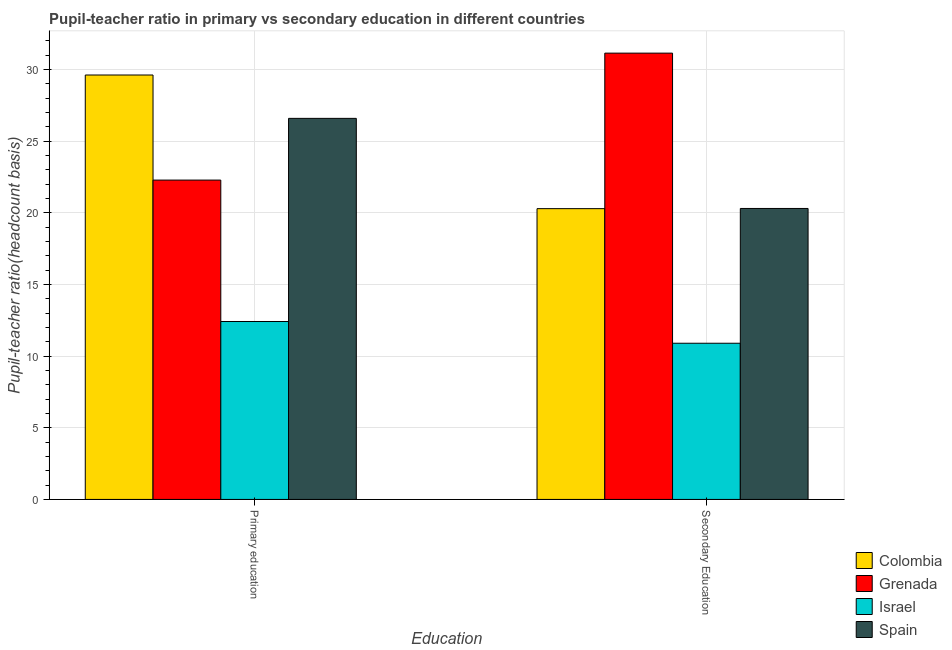How many groups of bars are there?
Your response must be concise. 2. Are the number of bars on each tick of the X-axis equal?
Ensure brevity in your answer.  Yes. What is the label of the 2nd group of bars from the left?
Ensure brevity in your answer.  Secondary Education. What is the pupil teacher ratio on secondary education in Israel?
Ensure brevity in your answer.  10.9. Across all countries, what is the maximum pupil teacher ratio on secondary education?
Give a very brief answer. 31.13. Across all countries, what is the minimum pupil-teacher ratio in primary education?
Give a very brief answer. 12.41. In which country was the pupil teacher ratio on secondary education maximum?
Your answer should be very brief. Grenada. In which country was the pupil teacher ratio on secondary education minimum?
Give a very brief answer. Israel. What is the total pupil teacher ratio on secondary education in the graph?
Offer a very short reply. 82.61. What is the difference between the pupil teacher ratio on secondary education in Spain and that in Grenada?
Keep it short and to the point. -10.84. What is the difference between the pupil teacher ratio on secondary education in Colombia and the pupil-teacher ratio in primary education in Israel?
Keep it short and to the point. 7.87. What is the average pupil teacher ratio on secondary education per country?
Ensure brevity in your answer.  20.65. What is the difference between the pupil teacher ratio on secondary education and pupil-teacher ratio in primary education in Israel?
Your response must be concise. -1.52. In how many countries, is the pupil teacher ratio on secondary education greater than 24 ?
Provide a succinct answer. 1. What is the ratio of the pupil-teacher ratio in primary education in Grenada to that in Spain?
Provide a succinct answer. 0.84. What does the 2nd bar from the left in Secondary Education represents?
Ensure brevity in your answer.  Grenada. What does the 3rd bar from the right in Secondary Education represents?
Offer a terse response. Grenada. Are all the bars in the graph horizontal?
Your answer should be compact. No. Does the graph contain any zero values?
Provide a short and direct response. No. Does the graph contain grids?
Provide a short and direct response. Yes. Where does the legend appear in the graph?
Offer a terse response. Bottom right. What is the title of the graph?
Offer a very short reply. Pupil-teacher ratio in primary vs secondary education in different countries. Does "Burundi" appear as one of the legend labels in the graph?
Provide a succinct answer. No. What is the label or title of the X-axis?
Keep it short and to the point. Education. What is the label or title of the Y-axis?
Offer a terse response. Pupil-teacher ratio(headcount basis). What is the Pupil-teacher ratio(headcount basis) of Colombia in Primary education?
Provide a succinct answer. 29.61. What is the Pupil-teacher ratio(headcount basis) in Grenada in Primary education?
Ensure brevity in your answer.  22.28. What is the Pupil-teacher ratio(headcount basis) in Israel in Primary education?
Ensure brevity in your answer.  12.41. What is the Pupil-teacher ratio(headcount basis) in Spain in Primary education?
Offer a terse response. 26.58. What is the Pupil-teacher ratio(headcount basis) of Colombia in Secondary Education?
Give a very brief answer. 20.29. What is the Pupil-teacher ratio(headcount basis) of Grenada in Secondary Education?
Your answer should be very brief. 31.13. What is the Pupil-teacher ratio(headcount basis) of Israel in Secondary Education?
Your response must be concise. 10.9. What is the Pupil-teacher ratio(headcount basis) in Spain in Secondary Education?
Offer a terse response. 20.3. Across all Education, what is the maximum Pupil-teacher ratio(headcount basis) of Colombia?
Your answer should be compact. 29.61. Across all Education, what is the maximum Pupil-teacher ratio(headcount basis) in Grenada?
Provide a short and direct response. 31.13. Across all Education, what is the maximum Pupil-teacher ratio(headcount basis) of Israel?
Your answer should be very brief. 12.41. Across all Education, what is the maximum Pupil-teacher ratio(headcount basis) of Spain?
Your answer should be very brief. 26.58. Across all Education, what is the minimum Pupil-teacher ratio(headcount basis) of Colombia?
Your response must be concise. 20.29. Across all Education, what is the minimum Pupil-teacher ratio(headcount basis) of Grenada?
Your answer should be very brief. 22.28. Across all Education, what is the minimum Pupil-teacher ratio(headcount basis) of Israel?
Your response must be concise. 10.9. Across all Education, what is the minimum Pupil-teacher ratio(headcount basis) of Spain?
Provide a succinct answer. 20.3. What is the total Pupil-teacher ratio(headcount basis) of Colombia in the graph?
Your answer should be very brief. 49.89. What is the total Pupil-teacher ratio(headcount basis) of Grenada in the graph?
Offer a very short reply. 53.41. What is the total Pupil-teacher ratio(headcount basis) of Israel in the graph?
Your response must be concise. 23.31. What is the total Pupil-teacher ratio(headcount basis) in Spain in the graph?
Give a very brief answer. 46.88. What is the difference between the Pupil-teacher ratio(headcount basis) in Colombia in Primary education and that in Secondary Education?
Offer a terse response. 9.32. What is the difference between the Pupil-teacher ratio(headcount basis) of Grenada in Primary education and that in Secondary Education?
Your response must be concise. -8.86. What is the difference between the Pupil-teacher ratio(headcount basis) of Israel in Primary education and that in Secondary Education?
Offer a very short reply. 1.52. What is the difference between the Pupil-teacher ratio(headcount basis) of Spain in Primary education and that in Secondary Education?
Make the answer very short. 6.28. What is the difference between the Pupil-teacher ratio(headcount basis) in Colombia in Primary education and the Pupil-teacher ratio(headcount basis) in Grenada in Secondary Education?
Ensure brevity in your answer.  -1.53. What is the difference between the Pupil-teacher ratio(headcount basis) in Colombia in Primary education and the Pupil-teacher ratio(headcount basis) in Israel in Secondary Education?
Offer a terse response. 18.71. What is the difference between the Pupil-teacher ratio(headcount basis) in Colombia in Primary education and the Pupil-teacher ratio(headcount basis) in Spain in Secondary Education?
Offer a very short reply. 9.31. What is the difference between the Pupil-teacher ratio(headcount basis) of Grenada in Primary education and the Pupil-teacher ratio(headcount basis) of Israel in Secondary Education?
Your response must be concise. 11.38. What is the difference between the Pupil-teacher ratio(headcount basis) of Grenada in Primary education and the Pupil-teacher ratio(headcount basis) of Spain in Secondary Education?
Your response must be concise. 1.98. What is the difference between the Pupil-teacher ratio(headcount basis) in Israel in Primary education and the Pupil-teacher ratio(headcount basis) in Spain in Secondary Education?
Provide a succinct answer. -7.89. What is the average Pupil-teacher ratio(headcount basis) of Colombia per Education?
Provide a short and direct response. 24.95. What is the average Pupil-teacher ratio(headcount basis) in Grenada per Education?
Give a very brief answer. 26.71. What is the average Pupil-teacher ratio(headcount basis) in Israel per Education?
Offer a very short reply. 11.65. What is the average Pupil-teacher ratio(headcount basis) in Spain per Education?
Give a very brief answer. 23.44. What is the difference between the Pupil-teacher ratio(headcount basis) of Colombia and Pupil-teacher ratio(headcount basis) of Grenada in Primary education?
Keep it short and to the point. 7.33. What is the difference between the Pupil-teacher ratio(headcount basis) of Colombia and Pupil-teacher ratio(headcount basis) of Israel in Primary education?
Offer a terse response. 17.2. What is the difference between the Pupil-teacher ratio(headcount basis) in Colombia and Pupil-teacher ratio(headcount basis) in Spain in Primary education?
Your response must be concise. 3.02. What is the difference between the Pupil-teacher ratio(headcount basis) in Grenada and Pupil-teacher ratio(headcount basis) in Israel in Primary education?
Your answer should be compact. 9.87. What is the difference between the Pupil-teacher ratio(headcount basis) of Grenada and Pupil-teacher ratio(headcount basis) of Spain in Primary education?
Your response must be concise. -4.31. What is the difference between the Pupil-teacher ratio(headcount basis) of Israel and Pupil-teacher ratio(headcount basis) of Spain in Primary education?
Your answer should be compact. -14.17. What is the difference between the Pupil-teacher ratio(headcount basis) in Colombia and Pupil-teacher ratio(headcount basis) in Grenada in Secondary Education?
Offer a terse response. -10.85. What is the difference between the Pupil-teacher ratio(headcount basis) of Colombia and Pupil-teacher ratio(headcount basis) of Israel in Secondary Education?
Keep it short and to the point. 9.39. What is the difference between the Pupil-teacher ratio(headcount basis) in Colombia and Pupil-teacher ratio(headcount basis) in Spain in Secondary Education?
Provide a succinct answer. -0.01. What is the difference between the Pupil-teacher ratio(headcount basis) of Grenada and Pupil-teacher ratio(headcount basis) of Israel in Secondary Education?
Keep it short and to the point. 20.24. What is the difference between the Pupil-teacher ratio(headcount basis) in Grenada and Pupil-teacher ratio(headcount basis) in Spain in Secondary Education?
Make the answer very short. 10.84. What is the difference between the Pupil-teacher ratio(headcount basis) in Israel and Pupil-teacher ratio(headcount basis) in Spain in Secondary Education?
Your answer should be very brief. -9.4. What is the ratio of the Pupil-teacher ratio(headcount basis) in Colombia in Primary education to that in Secondary Education?
Give a very brief answer. 1.46. What is the ratio of the Pupil-teacher ratio(headcount basis) of Grenada in Primary education to that in Secondary Education?
Make the answer very short. 0.72. What is the ratio of the Pupil-teacher ratio(headcount basis) in Israel in Primary education to that in Secondary Education?
Give a very brief answer. 1.14. What is the ratio of the Pupil-teacher ratio(headcount basis) in Spain in Primary education to that in Secondary Education?
Your response must be concise. 1.31. What is the difference between the highest and the second highest Pupil-teacher ratio(headcount basis) of Colombia?
Offer a very short reply. 9.32. What is the difference between the highest and the second highest Pupil-teacher ratio(headcount basis) of Grenada?
Offer a very short reply. 8.86. What is the difference between the highest and the second highest Pupil-teacher ratio(headcount basis) of Israel?
Keep it short and to the point. 1.52. What is the difference between the highest and the second highest Pupil-teacher ratio(headcount basis) in Spain?
Offer a very short reply. 6.28. What is the difference between the highest and the lowest Pupil-teacher ratio(headcount basis) in Colombia?
Your answer should be compact. 9.32. What is the difference between the highest and the lowest Pupil-teacher ratio(headcount basis) in Grenada?
Offer a very short reply. 8.86. What is the difference between the highest and the lowest Pupil-teacher ratio(headcount basis) in Israel?
Provide a short and direct response. 1.52. What is the difference between the highest and the lowest Pupil-teacher ratio(headcount basis) of Spain?
Provide a succinct answer. 6.28. 